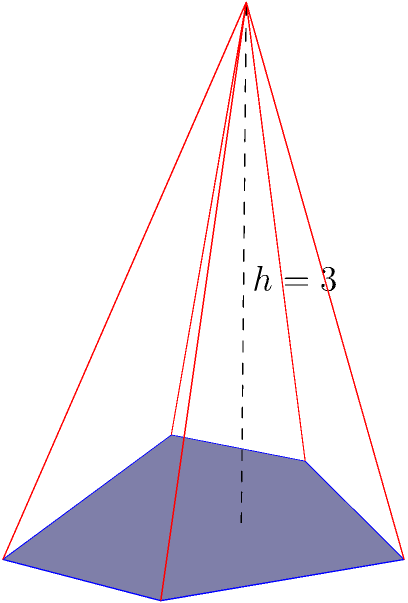A pyramid has an irregular pentagonal base with an area of 3 square units. The height of the pyramid is 3 units. What is the volume of this pyramid? To find the volume of a pyramid, we use the formula:

$$V = \frac{1}{3} \times A_{base} \times h$$

Where:
- $V$ is the volume of the pyramid
- $A_{base}$ is the area of the base
- $h$ is the height of the pyramid

Given:
- Area of the base, $A_{base} = 3$ square units
- Height of the pyramid, $h = 3$ units

Let's substitute these values into the formula:

$$V = \frac{1}{3} \times 3 \times 3$$

Simplifying:
$$V = \frac{1}{3} \times 9 = 3$$

Therefore, the volume of the pyramid is 3 cubic units.
Answer: 3 cubic units 